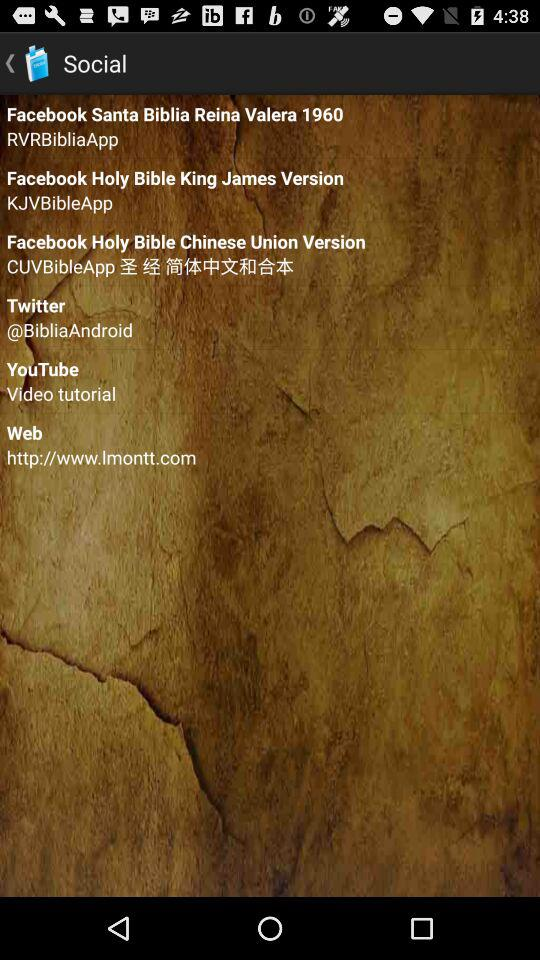On what platform can we watch "Video tutorial"? The platform on which we can watch "Video tutorial" is "YouTube". 